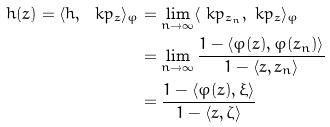<formula> <loc_0><loc_0><loc_500><loc_500>h ( z ) = \langle h , \ k p _ { z } \rangle _ { \varphi } & = \lim _ { n \to \infty } \langle \ k p _ { z _ { n } } , \ k p _ { z } \rangle _ { \varphi } \\ & = \lim _ { n \to \infty } \frac { 1 - \langle \varphi ( z ) , \varphi ( z _ { n } ) \rangle } { 1 - \langle z , z _ { n } \rangle } \\ & = \frac { 1 - \langle \varphi ( z ) , \xi \rangle } { 1 - \langle z , \zeta \rangle }</formula> 